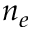Convert formula to latex. <formula><loc_0><loc_0><loc_500><loc_500>n _ { e }</formula> 